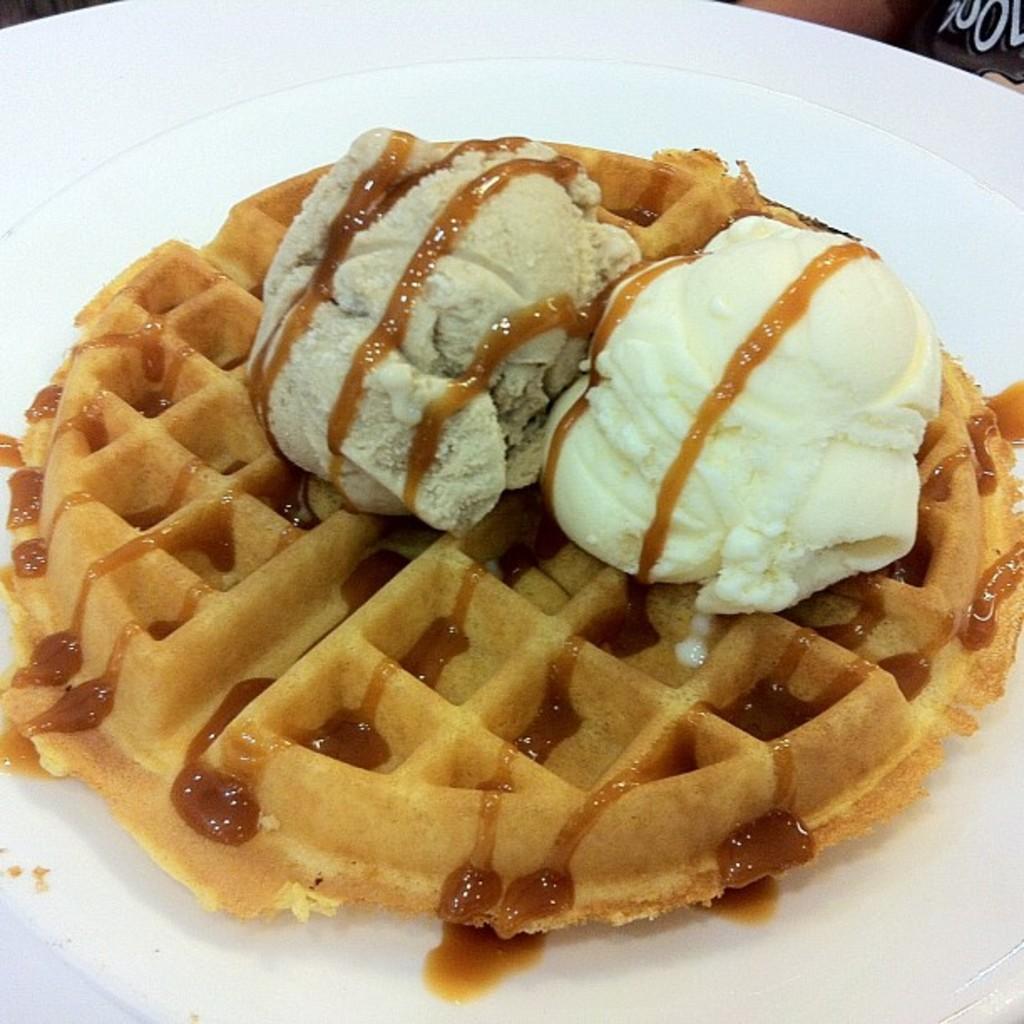How would you summarize this image in a sentence or two? In this image I can see a Belgian waffle in a plate. 